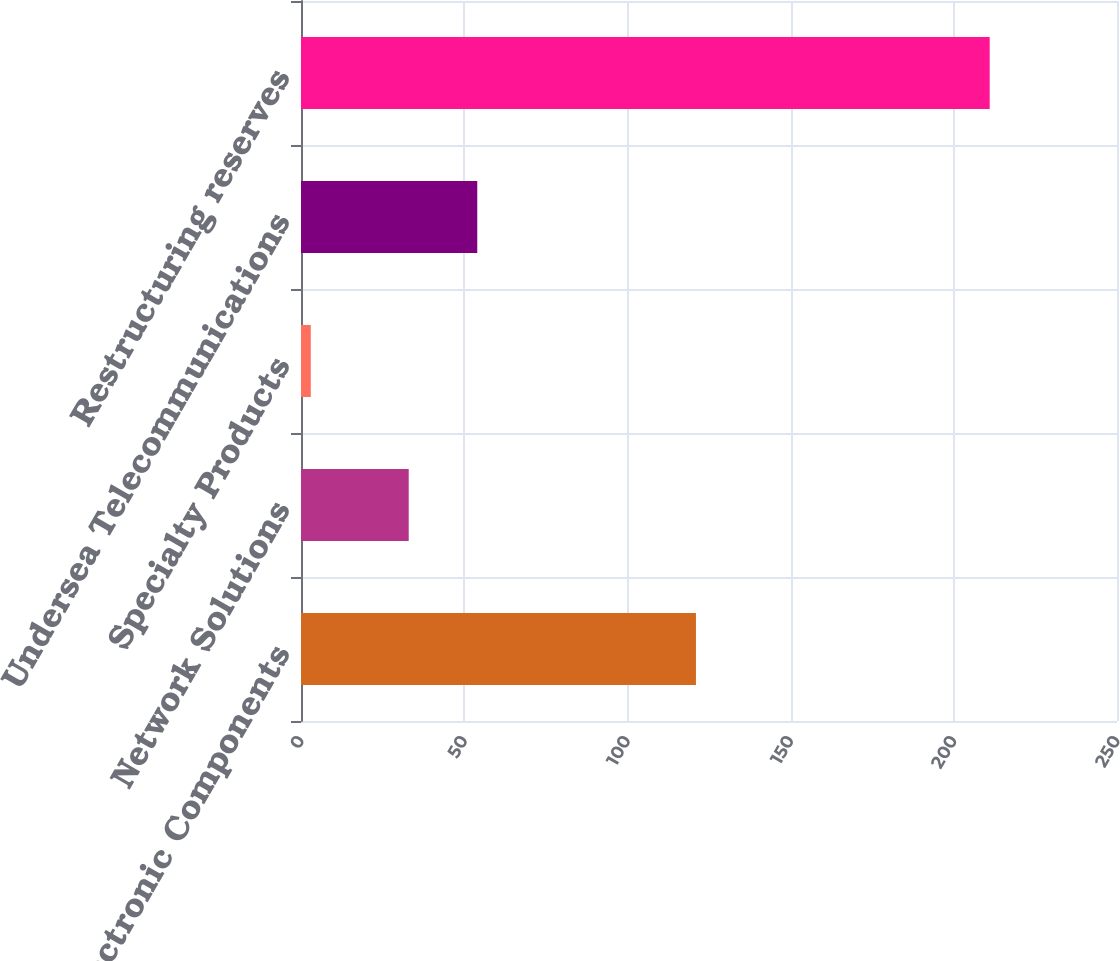Convert chart to OTSL. <chart><loc_0><loc_0><loc_500><loc_500><bar_chart><fcel>Electronic Components<fcel>Network Solutions<fcel>Specialty Products<fcel>Undersea Telecommunications<fcel>Restructuring reserves<nl><fcel>121<fcel>33<fcel>3<fcel>54<fcel>211<nl></chart> 